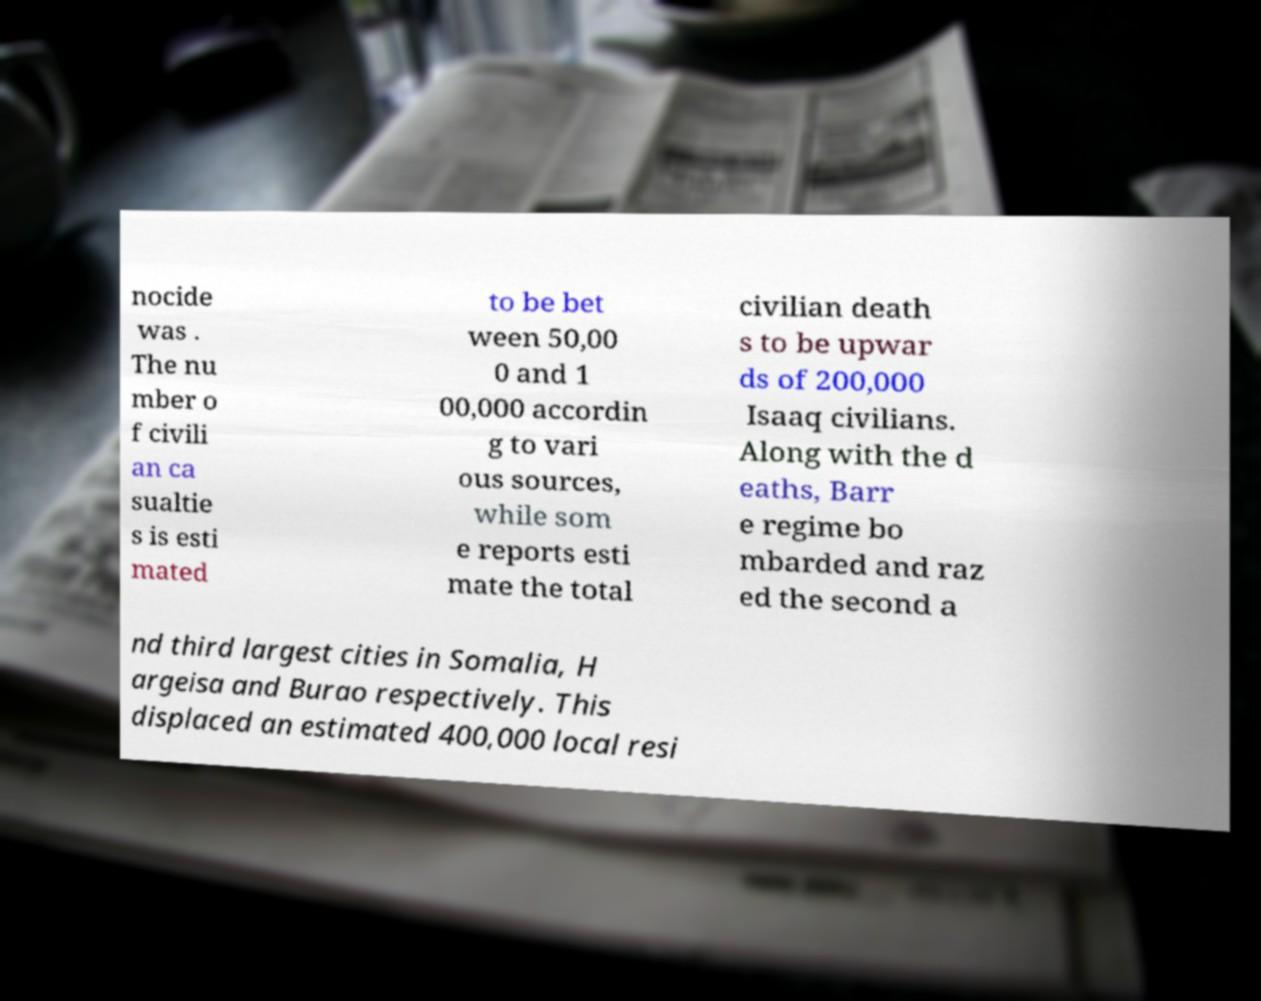I need the written content from this picture converted into text. Can you do that? nocide was . The nu mber o f civili an ca sualtie s is esti mated to be bet ween 50,00 0 and 1 00,000 accordin g to vari ous sources, while som e reports esti mate the total civilian death s to be upwar ds of 200,000 Isaaq civilians. Along with the d eaths, Barr e regime bo mbarded and raz ed the second a nd third largest cities in Somalia, H argeisa and Burao respectively. This displaced an estimated 400,000 local resi 